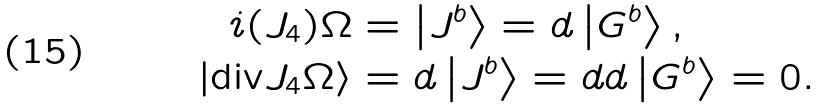<formula> <loc_0><loc_0><loc_500><loc_500>i ( J _ { 4 } ) \Omega & = \left | J ^ { b } \right \rangle = d \left | G ^ { b } \right \rangle , \\ \left | \text {div} J _ { 4 } \Omega \right \rangle & = d \left | J ^ { b } \right \rangle = d d \left | G ^ { b } \right \rangle = 0 .</formula> 